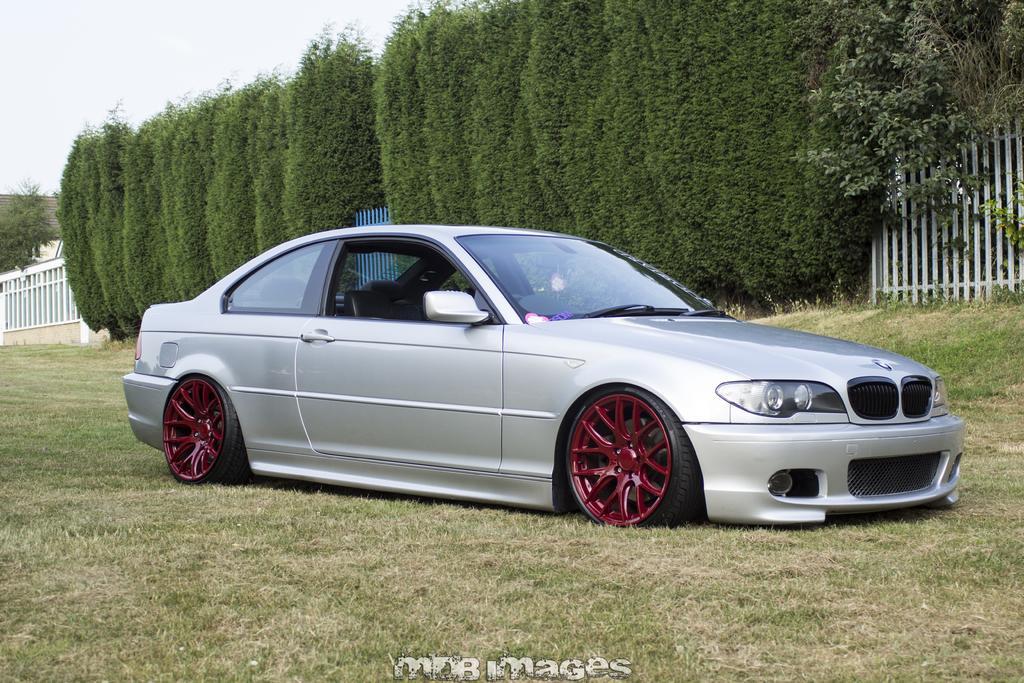Could you give a brief overview of what you see in this image? In this image we can see a silver color car parked on the grass. In the background, we can see trees, fence, roof and the sky in the background. 